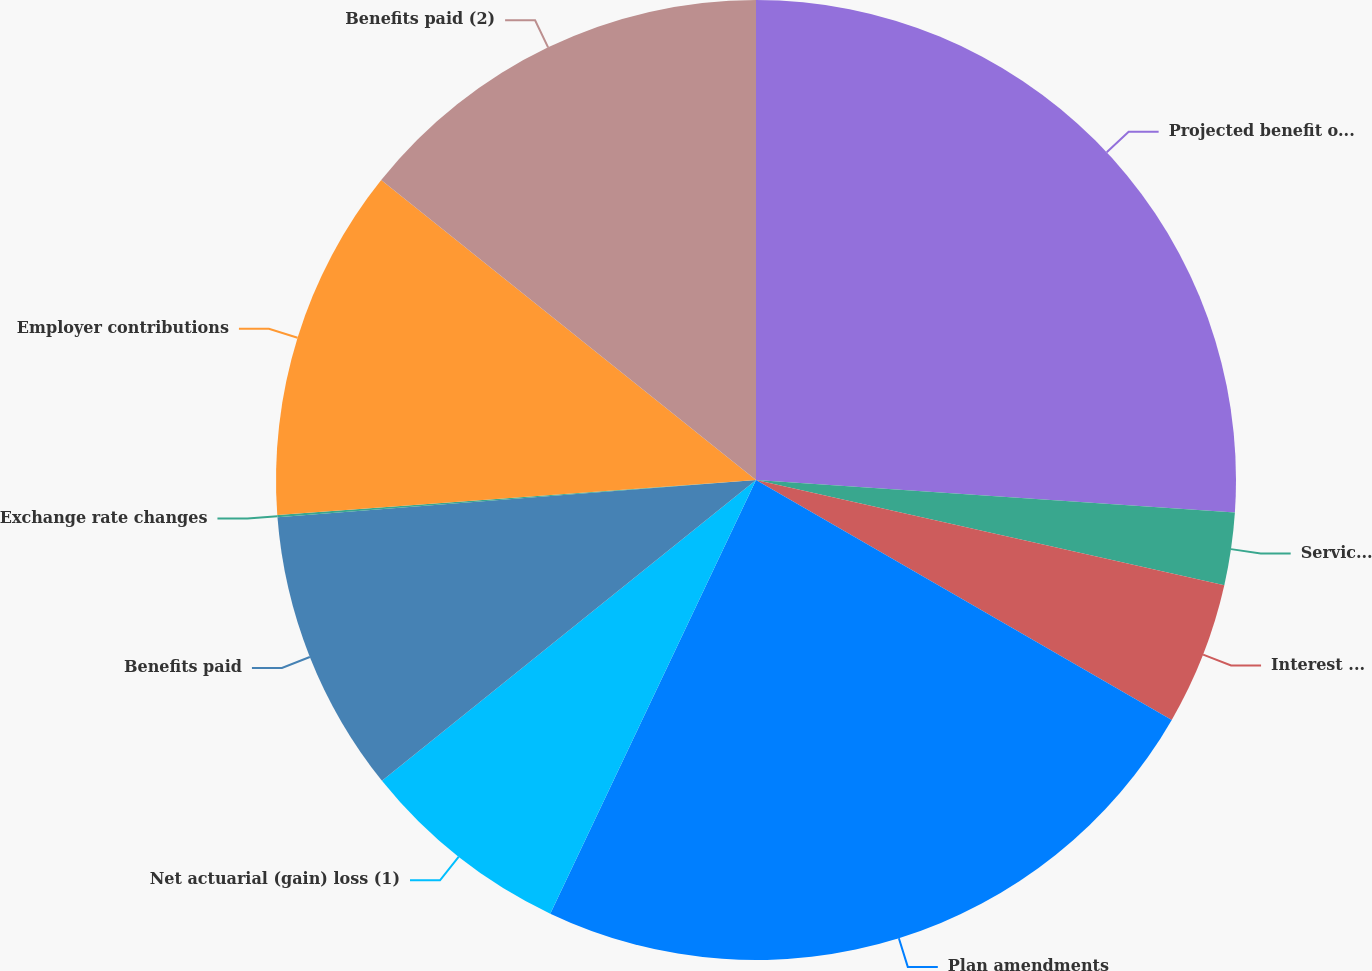Convert chart. <chart><loc_0><loc_0><loc_500><loc_500><pie_chart><fcel>Projected benefit obligation<fcel>Service cost<fcel>Interest cost<fcel>Plan amendments<fcel>Net actuarial (gain) loss (1)<fcel>Benefits paid<fcel>Exchange rate changes<fcel>Employer contributions<fcel>Benefits paid (2)<nl><fcel>26.08%<fcel>2.44%<fcel>4.81%<fcel>23.72%<fcel>7.17%<fcel>9.54%<fcel>0.08%<fcel>11.9%<fcel>14.26%<nl></chart> 